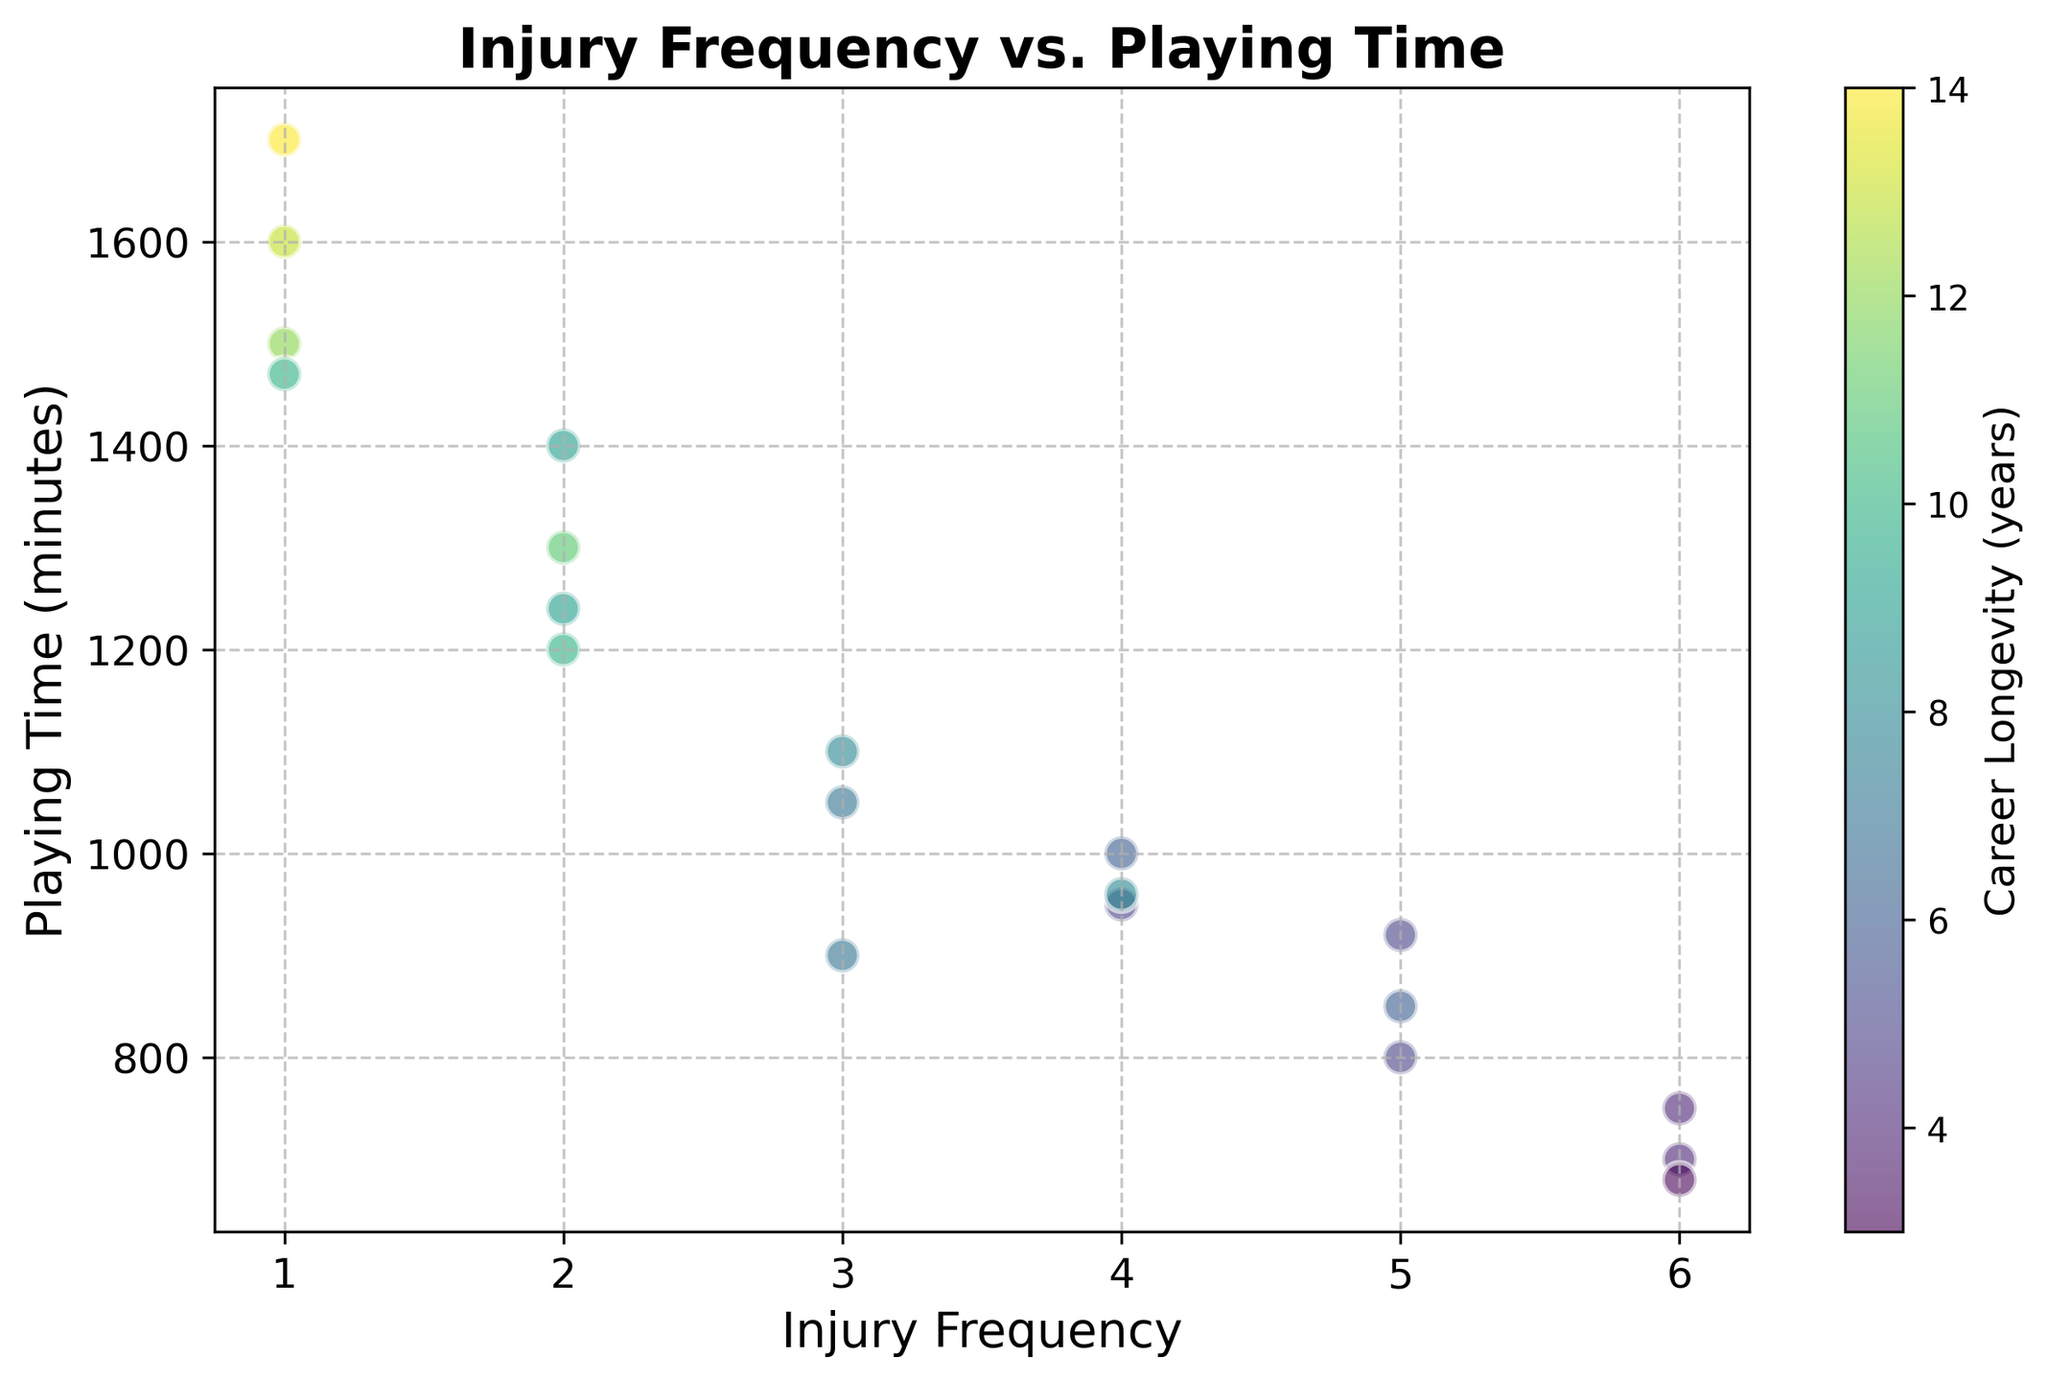What's the relationship between higher injury frequency and career longevity? By looking at the scatter plot, we observe the colors indicating career longevity. Players with higher injury frequencies tend to have shorter career longevity, as indicated by the lighter colors on the right side of the plot.
Answer: Inversely correlated Which player has the longest career longevity and what is their playing time? The player with the longest career longevity has the darkest color (deep purple) on the plot. This player has a playing time of around 1700 minutes.
Answer: 14 years, 1700 minutes What's the average injury frequency for players with a playing time over 1300 minutes? By identifying the scatter points where playing time is more than 1300 minutes, we find the injury frequencies: 1, 1, 2, and 2. Average = (1+1+2+2)/4 = 1.5.
Answer: 1.5 Comparing players with career longevity of 10 years, who has higher playing time and lower injury frequency? There are points representing players with 10 years of career longevity shown in deeper shades compared to adjacent points. Player IDs 1 and 15 correspond to these conditions. Player 15 has higher playing time of 1470 vs 1200 and lower injury frequency of 1 vs 2.
Answer: Player 15 Which player has the highest playing time with a career longevity of less than 10 years? We look for the most rightward data points that are not dark in color. The player with playing time of 1240 minutes (player ID 16) has a career longevity of 9 years.
Answer: Player ID 16 Is there a noticeable visual trend between playing time and career longevity? Observing the scatter plot, darker colors, indicating longer careers, often correspond to higher playing times, suggesting a positive correlation between playing time and career longevity.
Answer: Yes How does the injury frequency of players with 9 years of career longevity compare to each other? Players with 9 years of career longevity have different injury frequencies: Player IDs 11 and 16 with frequencies of 2 and 2 respectively, indicating they have the same injury frequency.
Answer: Same (2) What can you infer about the player distribution in terms of injury frequency and career longevity? The scatter plot shows that players with lower injury frequencies clustered on the left, often have longer careers (darker colors), suggesting lower injury frequency may contribute to longer career longevity.
Answer: Lower injury frequency tends to correlate with longer careers How many players have playing times between 700 and 1000 minutes, and what are their career longevities? By checking scatter points within the playing time range of 700 to 1000, we find players IDs 5, 12, 13, and 18 with longevities of 4, 4, 5, and 8 years respectively.
Answer: 4 players; 4, 4, 5, 8 years Which player has the shortest career longevity and what is their playing time and injury frequency? The player with the shortest career longevity has the lightest color (yellowish). This player has a career longevity of 3 years, a playing time of 680 minutes, and an injury frequency of 6.
Answer: Player ID 19; 680 minutes; 6 